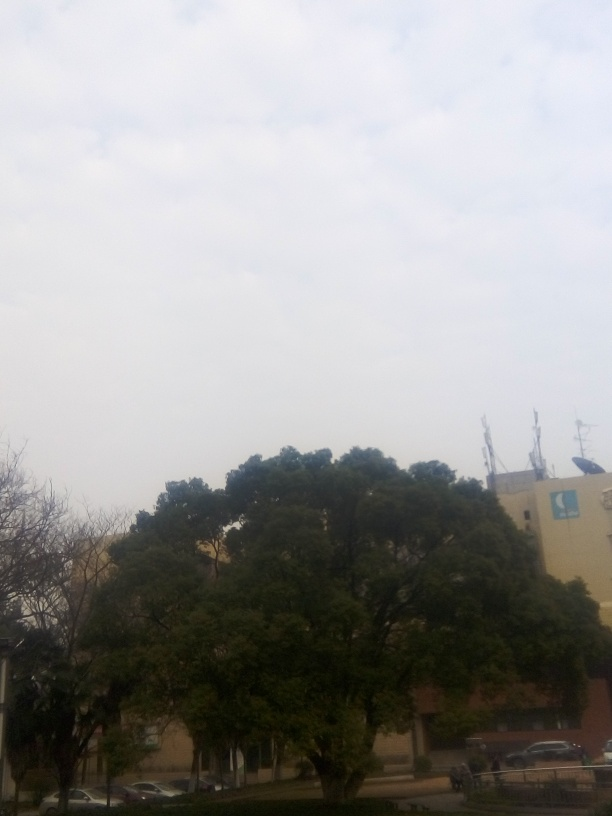What is the weather like in this picture? The overcast sky suggests it's a cloudy day, likely without direct sunlight, which might indicate cooler temperatures and a chance of rain. Are there any signs of human activity? There are few direct signs of human activity. However, we can infer presence due to the cars parked nearby and the appearance of structured pathways and buildings. 